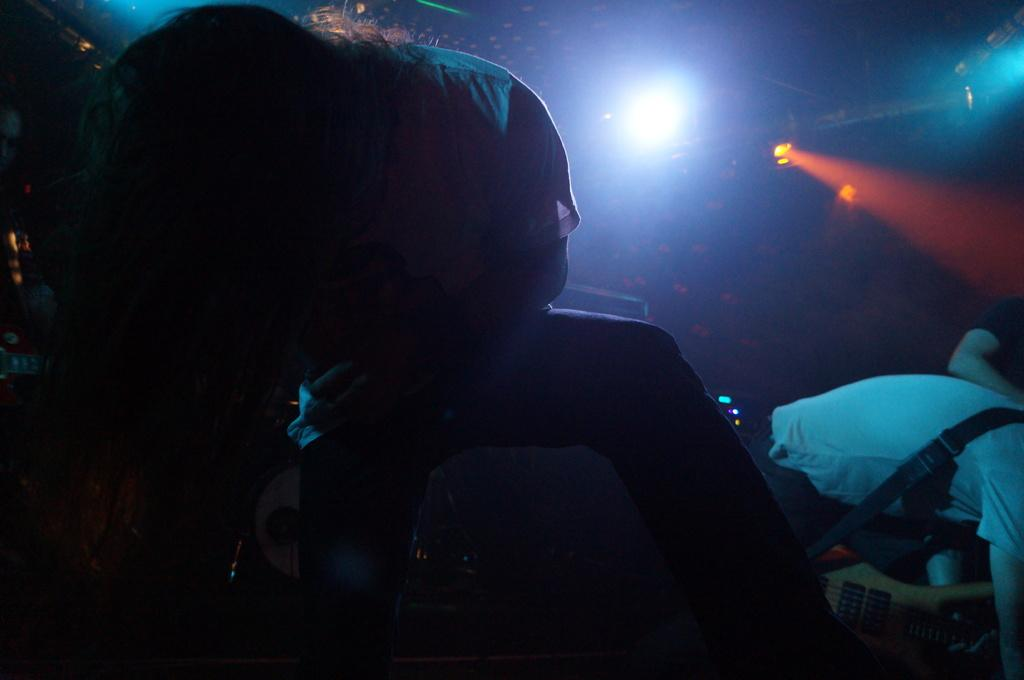Who or what can be seen in the image? There are people in the image. What is one specific object that can be seen in the image? There is a guitar in the image. What type of illumination is present in the image? There are lights in the image. Can you describe any other objects present in the image? There are other objects in the image, but their specific details are not mentioned in the provided facts. How would you describe the overall lighting condition in the image? The background of the image is dark. What type of dress is being adjusted in the image? There is no dress present in the image, nor is there any indication of an adjustment being made. 